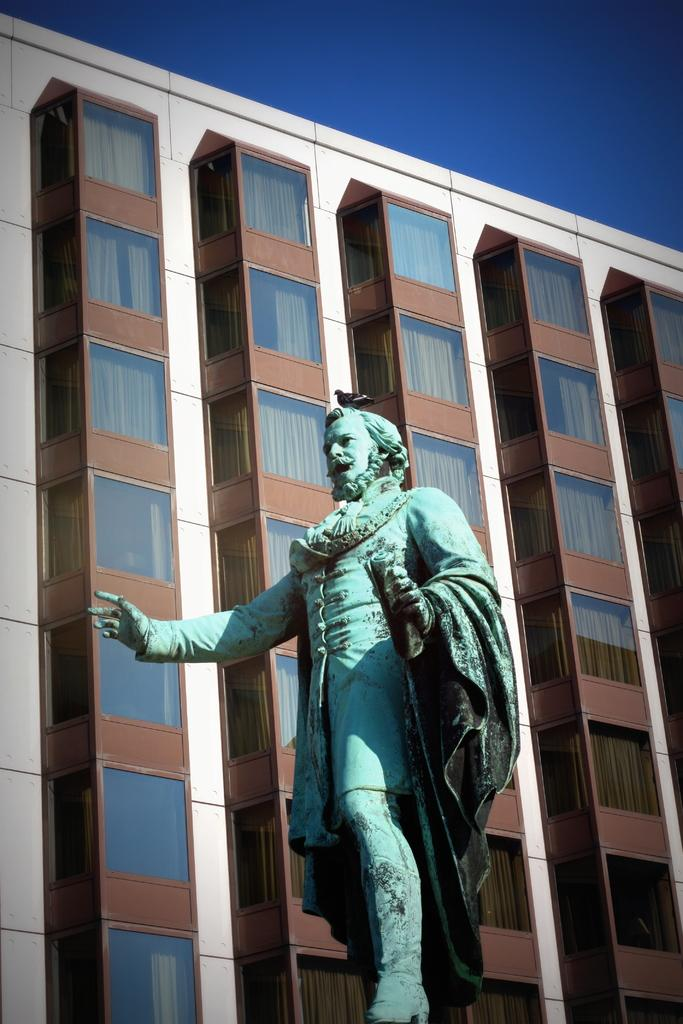What is the main subject of the image? There is a sculpture present in the image. What can be seen in the background of the image? There is a building with glass windows in the background of the image. What is visible at the top of the image? The sky is visible at the top of the image. How many eggs are being used to create the sculpture in the image? There is no indication in the image that eggs are being used to create the sculpture, and therefore no such information can be provided. 